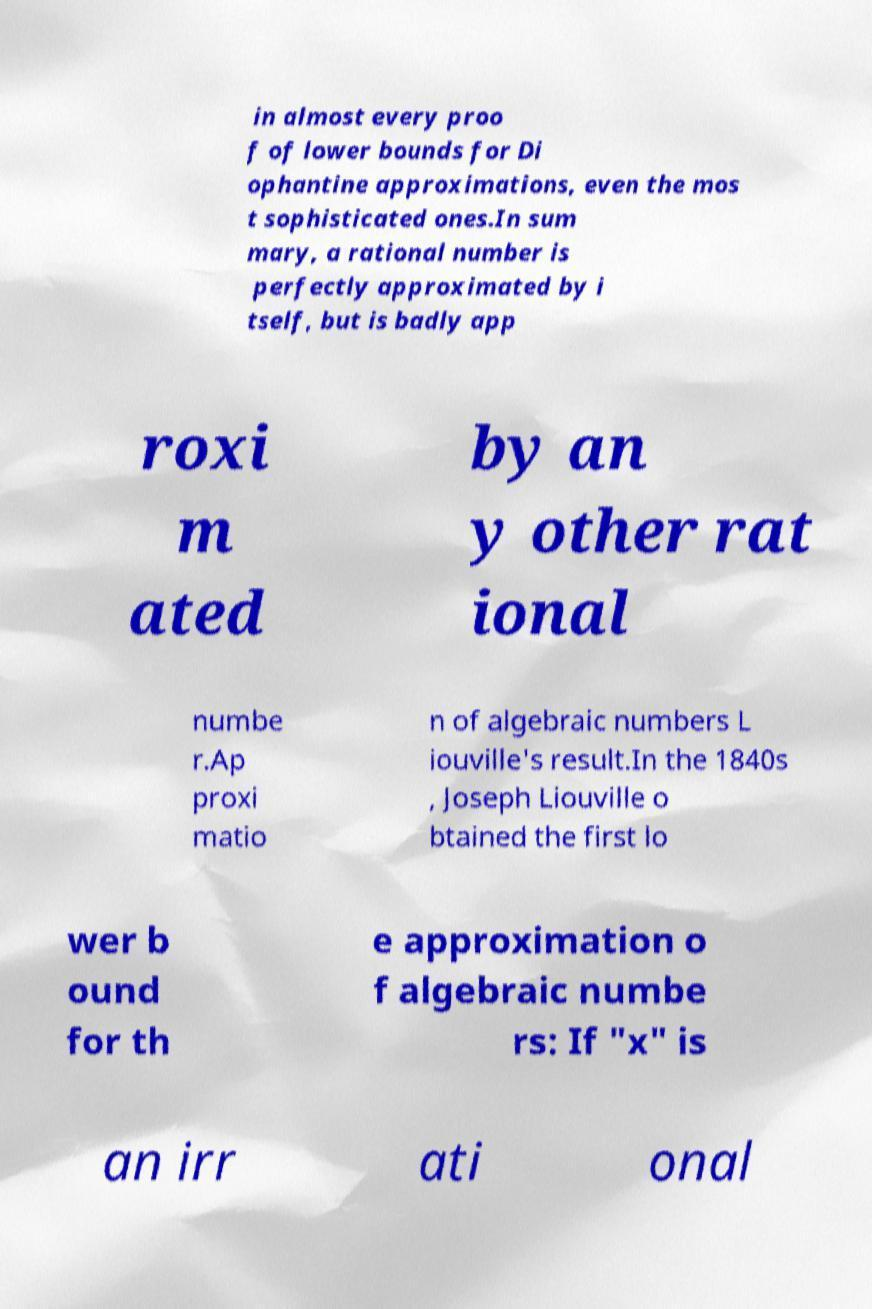I need the written content from this picture converted into text. Can you do that? in almost every proo f of lower bounds for Di ophantine approximations, even the mos t sophisticated ones.In sum mary, a rational number is perfectly approximated by i tself, but is badly app roxi m ated by an y other rat ional numbe r.Ap proxi matio n of algebraic numbers L iouville's result.In the 1840s , Joseph Liouville o btained the first lo wer b ound for th e approximation o f algebraic numbe rs: If "x" is an irr ati onal 